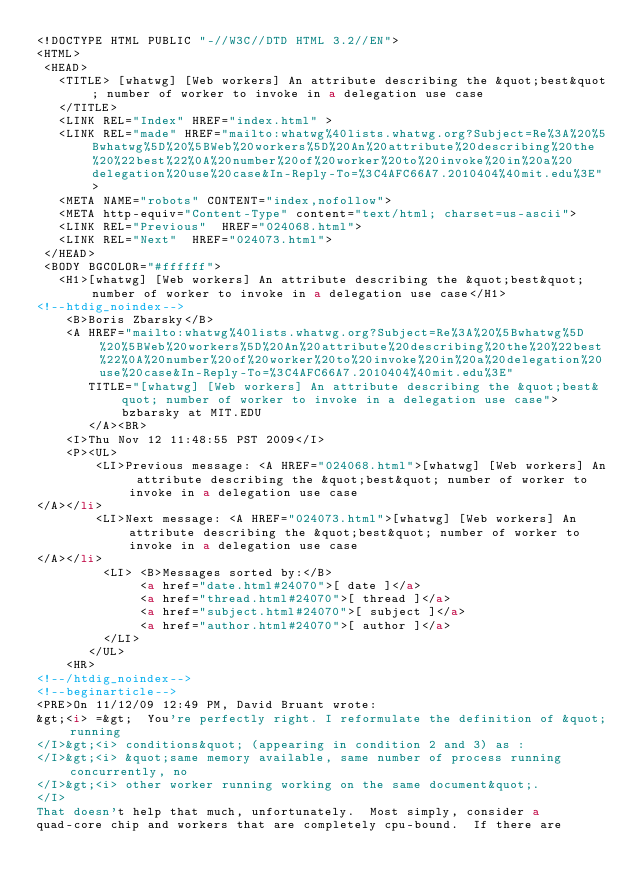<code> <loc_0><loc_0><loc_500><loc_500><_HTML_><!DOCTYPE HTML PUBLIC "-//W3C//DTD HTML 3.2//EN">
<HTML>
 <HEAD>
   <TITLE> [whatwg] [Web workers] An attribute describing the &quot;best&quot; number of worker to invoke in a delegation use case
   </TITLE>
   <LINK REL="Index" HREF="index.html" >
   <LINK REL="made" HREF="mailto:whatwg%40lists.whatwg.org?Subject=Re%3A%20%5Bwhatwg%5D%20%5BWeb%20workers%5D%20An%20attribute%20describing%20the%20%22best%22%0A%20number%20of%20worker%20to%20invoke%20in%20a%20delegation%20use%20case&In-Reply-To=%3C4AFC66A7.2010404%40mit.edu%3E">
   <META NAME="robots" CONTENT="index,nofollow">
   <META http-equiv="Content-Type" content="text/html; charset=us-ascii">
   <LINK REL="Previous"  HREF="024068.html">
   <LINK REL="Next"  HREF="024073.html">
 </HEAD>
 <BODY BGCOLOR="#ffffff">
   <H1>[whatwg] [Web workers] An attribute describing the &quot;best&quot; number of worker to invoke in a delegation use case</H1>
<!--htdig_noindex-->
    <B>Boris Zbarsky</B> 
    <A HREF="mailto:whatwg%40lists.whatwg.org?Subject=Re%3A%20%5Bwhatwg%5D%20%5BWeb%20workers%5D%20An%20attribute%20describing%20the%20%22best%22%0A%20number%20of%20worker%20to%20invoke%20in%20a%20delegation%20use%20case&In-Reply-To=%3C4AFC66A7.2010404%40mit.edu%3E"
       TITLE="[whatwg] [Web workers] An attribute describing the &quot;best&quot; number of worker to invoke in a delegation use case">bzbarsky at MIT.EDU
       </A><BR>
    <I>Thu Nov 12 11:48:55 PST 2009</I>
    <P><UL>
        <LI>Previous message: <A HREF="024068.html">[whatwg] [Web workers] An attribute describing the &quot;best&quot; number of worker to invoke in a delegation use case
</A></li>
        <LI>Next message: <A HREF="024073.html">[whatwg] [Web workers] An attribute describing the &quot;best&quot; number of worker to invoke in a delegation use case
</A></li>
         <LI> <B>Messages sorted by:</B> 
              <a href="date.html#24070">[ date ]</a>
              <a href="thread.html#24070">[ thread ]</a>
              <a href="subject.html#24070">[ subject ]</a>
              <a href="author.html#24070">[ author ]</a>
         </LI>
       </UL>
    <HR>  
<!--/htdig_noindex-->
<!--beginarticle-->
<PRE>On 11/12/09 12:49 PM, David Bruant wrote:
&gt;<i> =&gt;  You're perfectly right. I reformulate the definition of &quot;running
</I>&gt;<i> conditions&quot; (appearing in condition 2 and 3) as :
</I>&gt;<i> &quot;same memory available, same number of process running concurrently, no
</I>&gt;<i> other worker running working on the same document&quot;.
</I>
That doesn't help that much, unfortunately.  Most simply, consider a 
quad-core chip and workers that are completely cpu-bound.  If there are </code> 